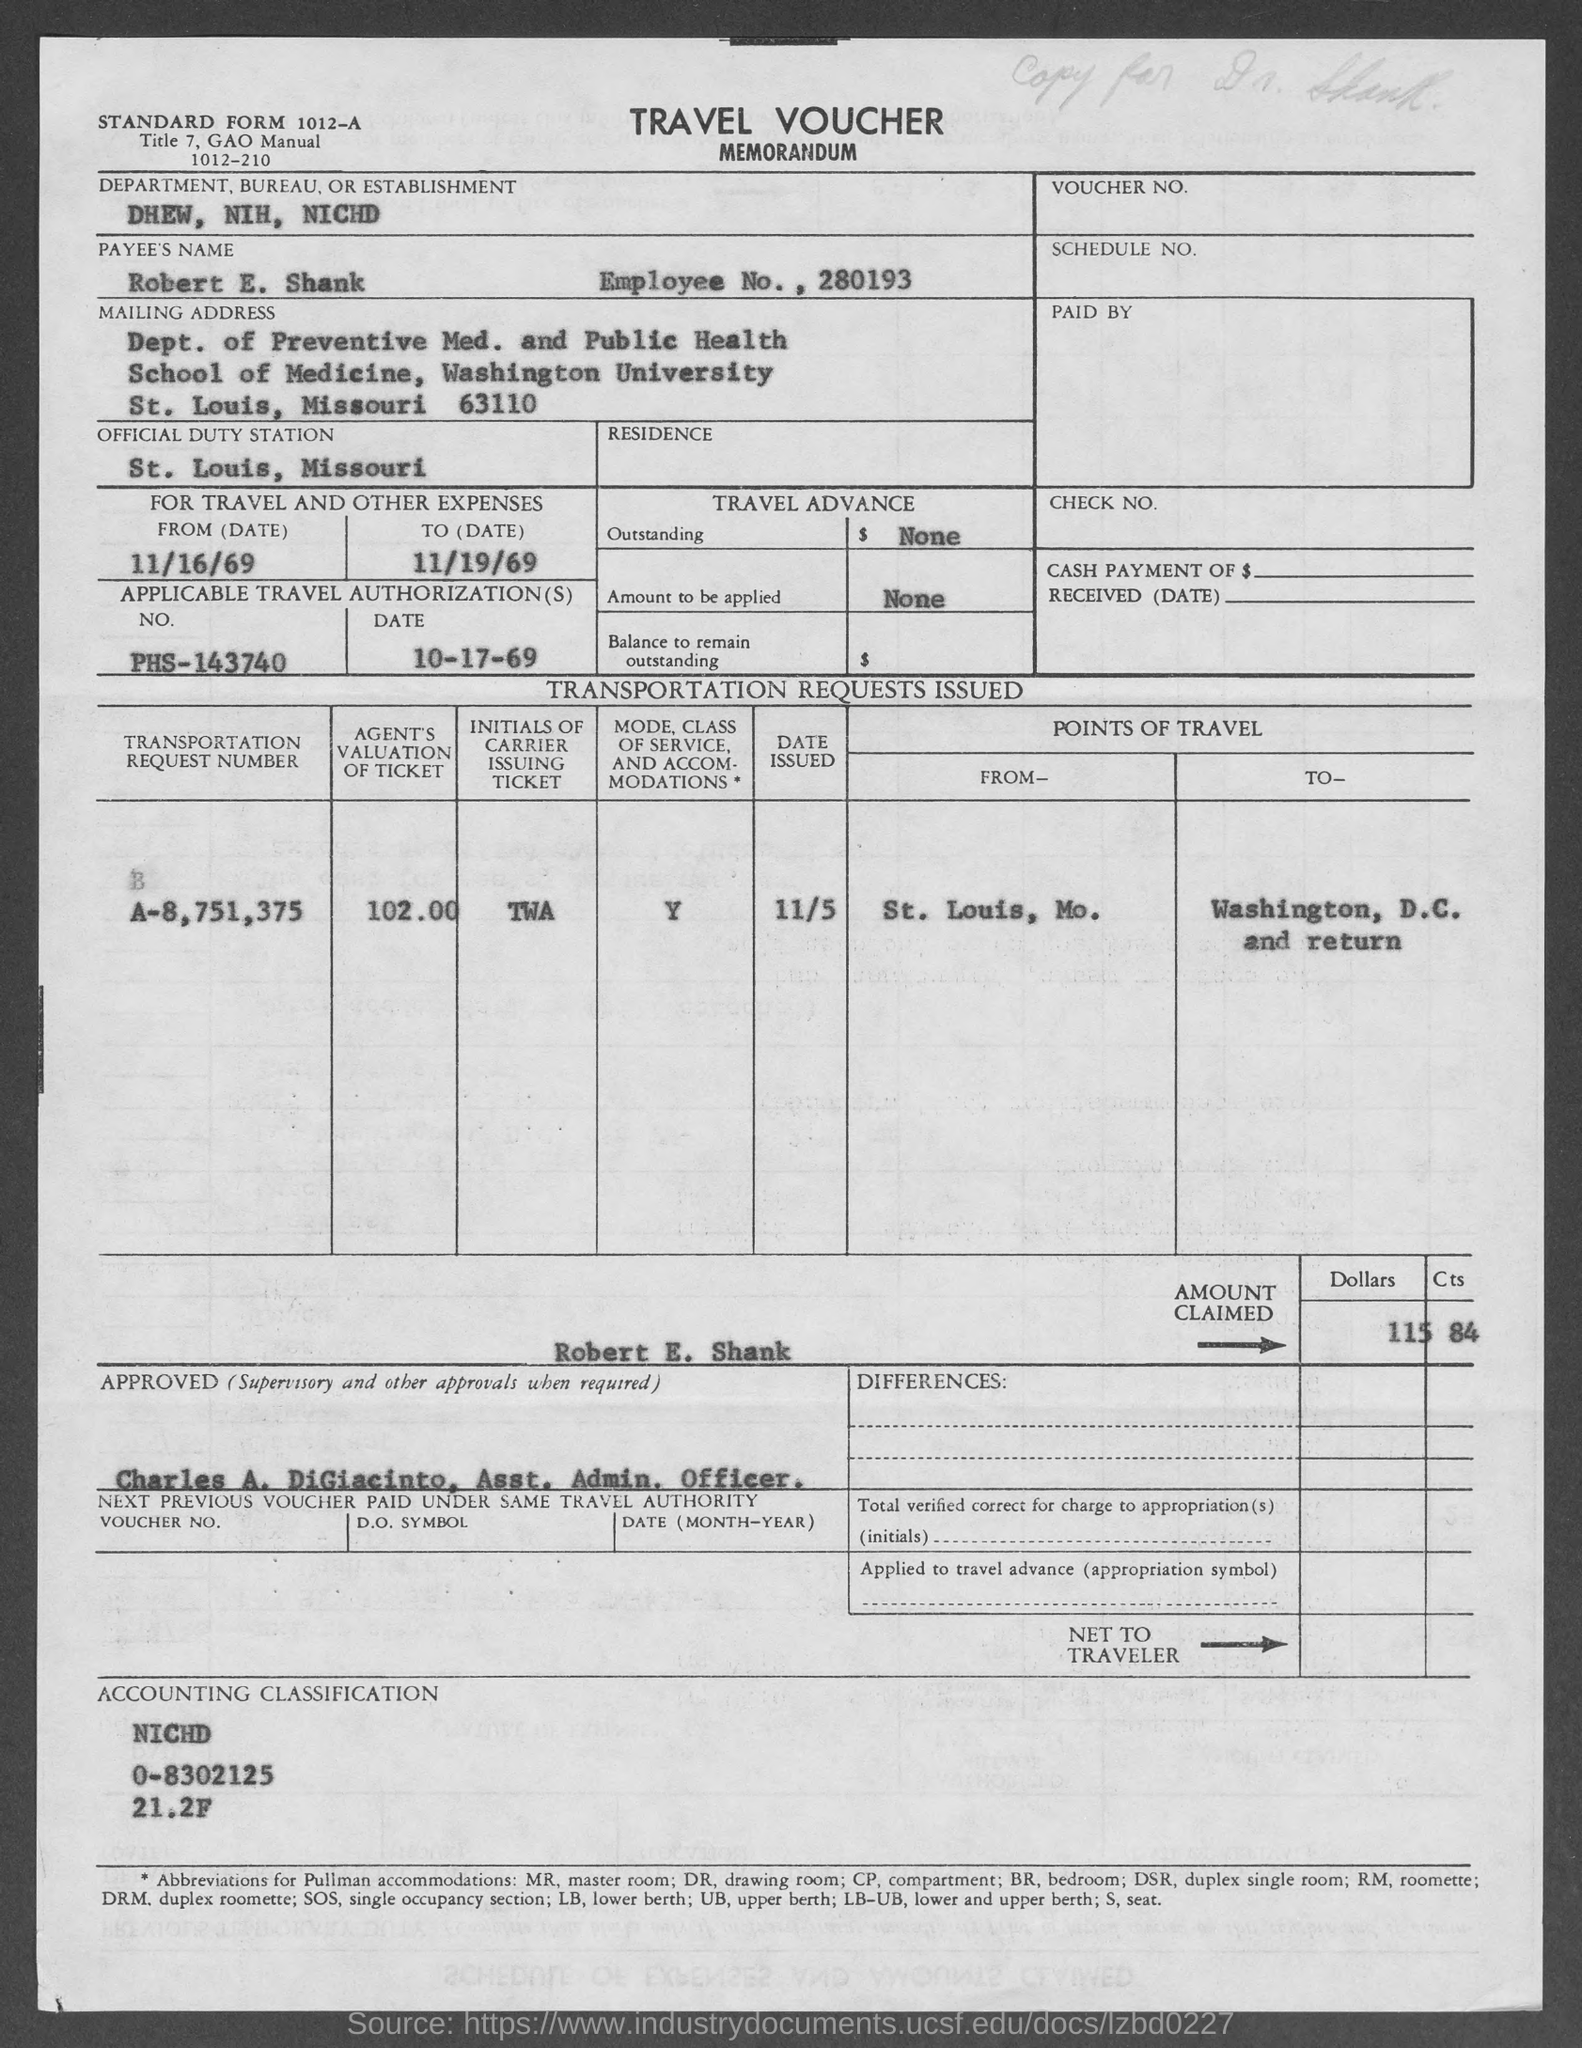List a handful of essential elements in this visual. The transportation request number mentioned in the travel voucher is A-8,751,375. The payee's name listed in the voucher is Robert E. Shank. Robert E. Shank's employee number is 280193. The department, bureau, or establishment mentioned in the voucher is the Department of Health, Education, and Welfare (DHEW), the National Institutes of Health (NIH), and the National Institute of Child Health and Human Development (NICHD). On the travel voucher, the applicable travel authorization date is 10-17-69. 